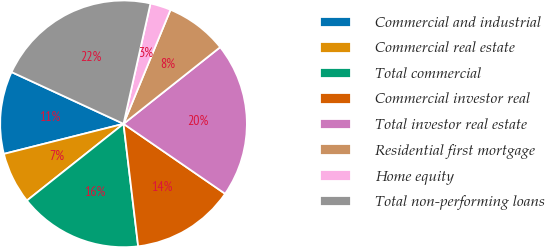Convert chart to OTSL. <chart><loc_0><loc_0><loc_500><loc_500><pie_chart><fcel>Commercial and industrial<fcel>Commercial real estate<fcel>Total commercial<fcel>Commercial investor real<fcel>Total investor real estate<fcel>Residential first mortgage<fcel>Home equity<fcel>Total non-performing loans<nl><fcel>10.81%<fcel>6.76%<fcel>16.21%<fcel>13.51%<fcel>20.26%<fcel>8.11%<fcel>2.71%<fcel>21.61%<nl></chart> 